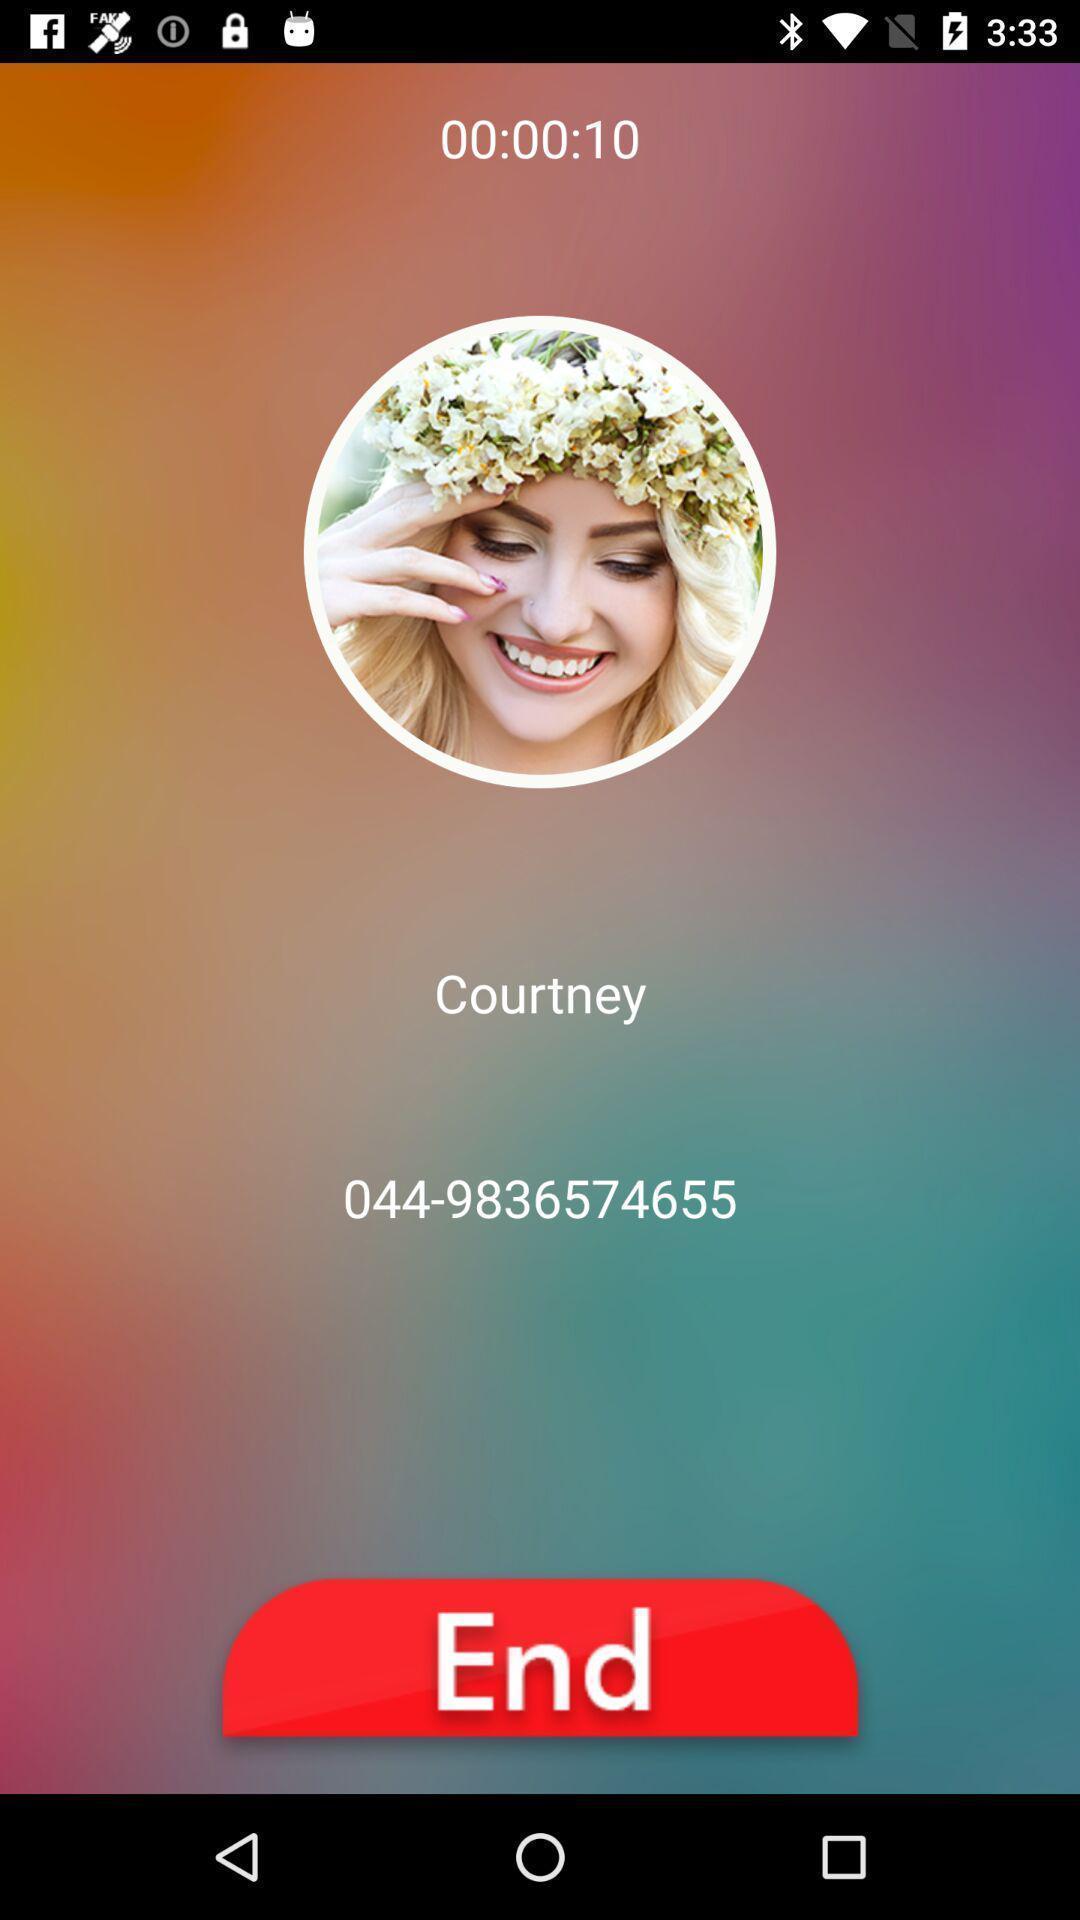Provide a description of this screenshot. Page showing ongoing call with an image. 